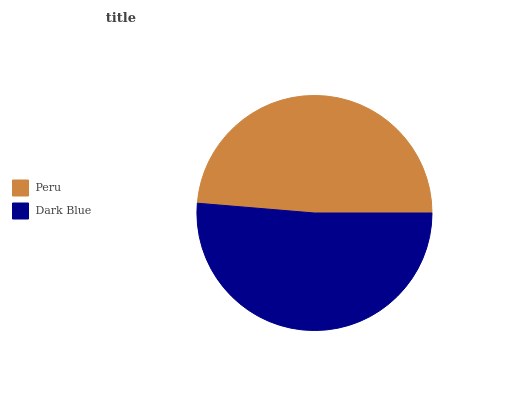Is Peru the minimum?
Answer yes or no. Yes. Is Dark Blue the maximum?
Answer yes or no. Yes. Is Dark Blue the minimum?
Answer yes or no. No. Is Dark Blue greater than Peru?
Answer yes or no. Yes. Is Peru less than Dark Blue?
Answer yes or no. Yes. Is Peru greater than Dark Blue?
Answer yes or no. No. Is Dark Blue less than Peru?
Answer yes or no. No. Is Dark Blue the high median?
Answer yes or no. Yes. Is Peru the low median?
Answer yes or no. Yes. Is Peru the high median?
Answer yes or no. No. Is Dark Blue the low median?
Answer yes or no. No. 